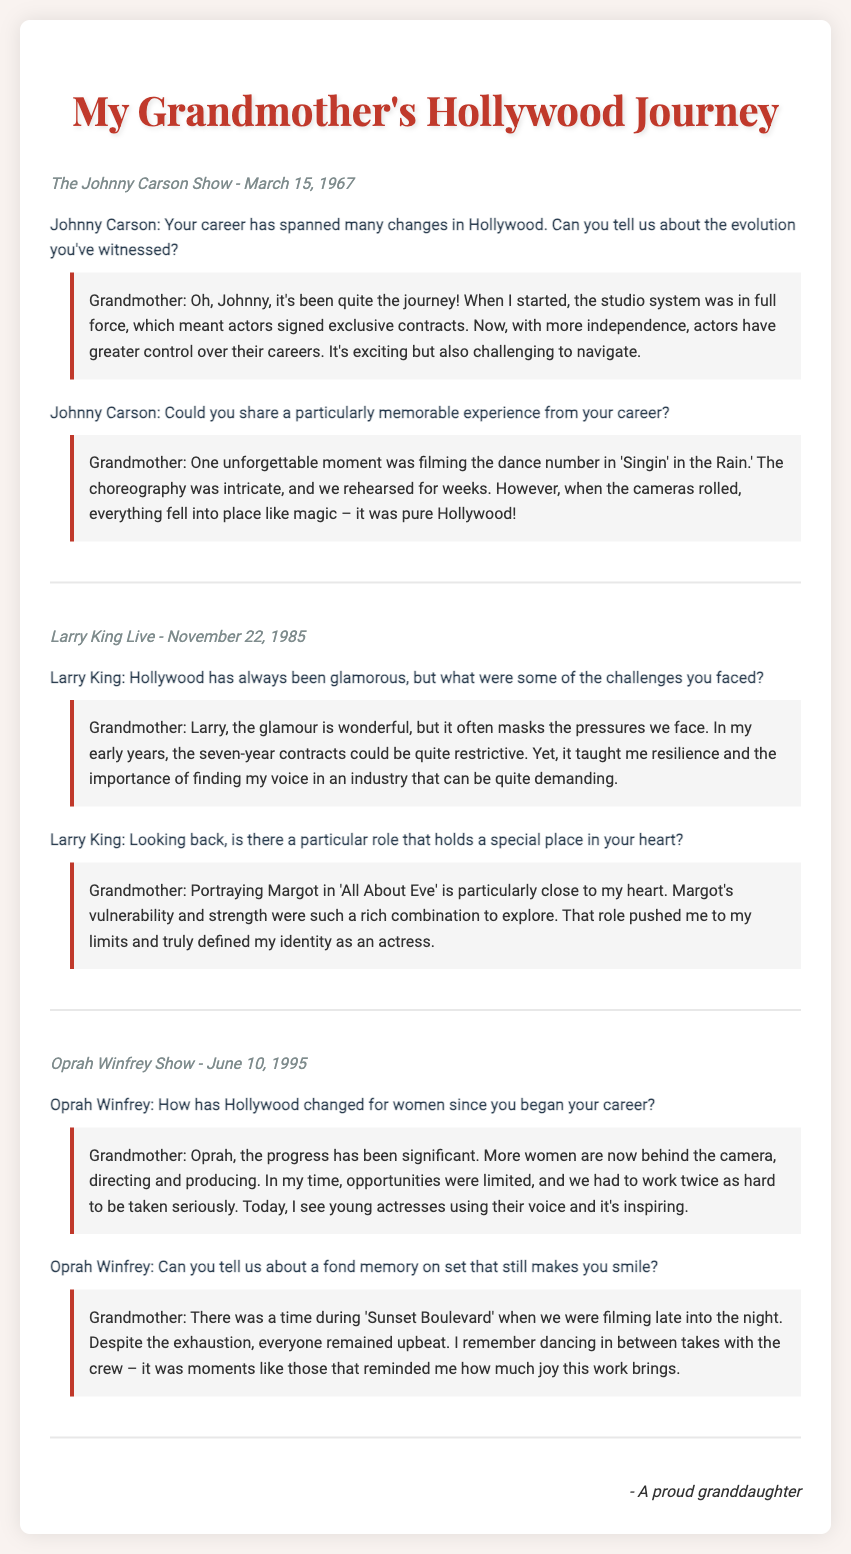What show did your grandmother appear on March 15, 1967? The document mentions "The Johnny Carson Show" as the show on that date.
Answer: The Johnny Carson Show What role is particularly close to your grandmother's heart? She stated that portraying Margot in 'All About Eve' holds a special place in her heart.
Answer: Margot in 'All About Eve' What significant change for women in Hollywood did your grandmother note? She highlighted that more women are now behind the camera directing and producing compared to her early career.
Answer: More women behind the camera What memorable experience did she mention from 'Singin' in the Rain'? She described that filming the dance number was an unforgettable moment full of intricate choreography.
Answer: Dance number in 'Singin' in the Rain In what year did your grandmother appear on Larry King Live? The document specifies that her appearance was on November 22, 1985.
Answer: 1985 